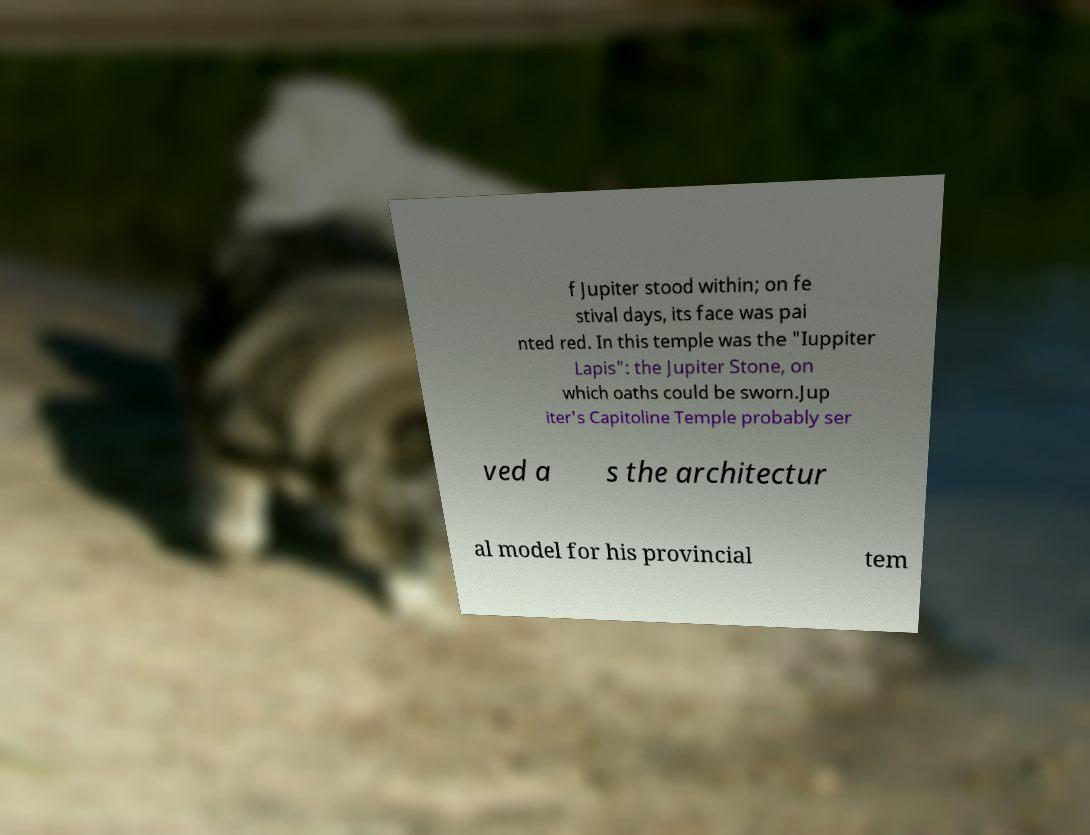Can you accurately transcribe the text from the provided image for me? f Jupiter stood within; on fe stival days, its face was pai nted red. In this temple was the "Iuppiter Lapis": the Jupiter Stone, on which oaths could be sworn.Jup iter's Capitoline Temple probably ser ved a s the architectur al model for his provincial tem 